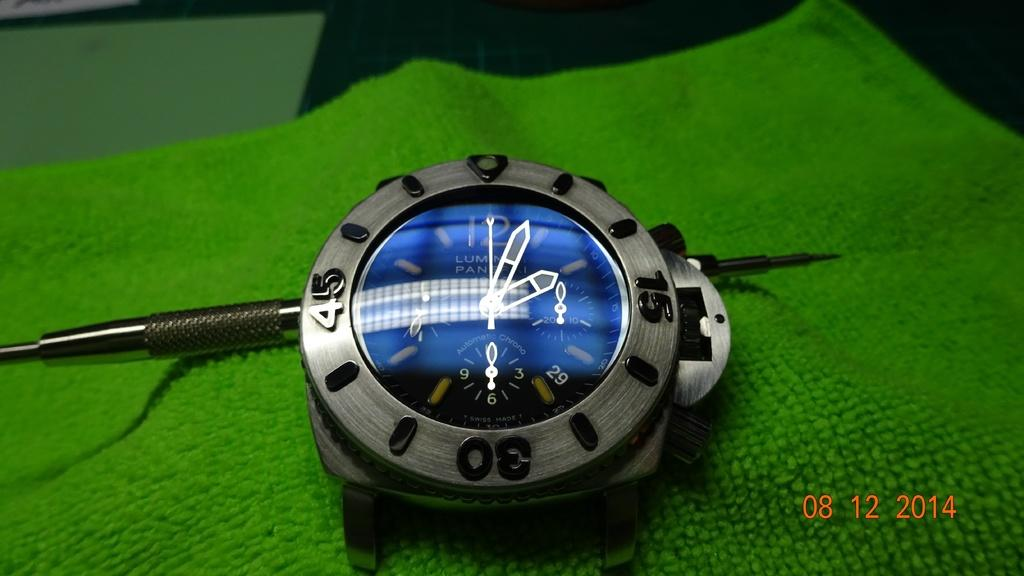<image>
Create a compact narrative representing the image presented. The Swiss Made watch is lying on a green cloth. 